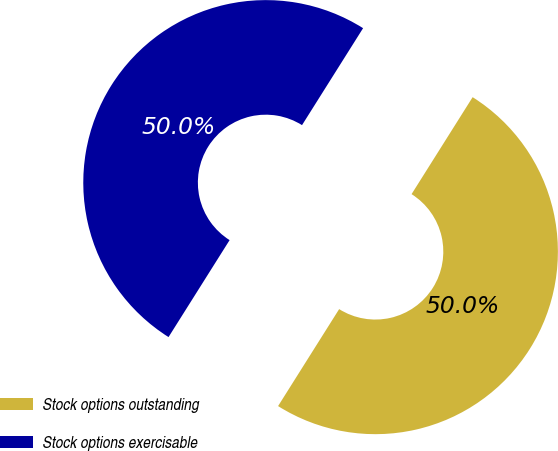<chart> <loc_0><loc_0><loc_500><loc_500><pie_chart><fcel>Stock options outstanding<fcel>Stock options exercisable<nl><fcel>50.0%<fcel>50.0%<nl></chart> 